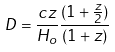<formula> <loc_0><loc_0><loc_500><loc_500>D = \frac { c z } { H _ { o } } { \frac { ( 1 + \frac { z } { 2 } ) } { ( 1 + z ) } }</formula> 